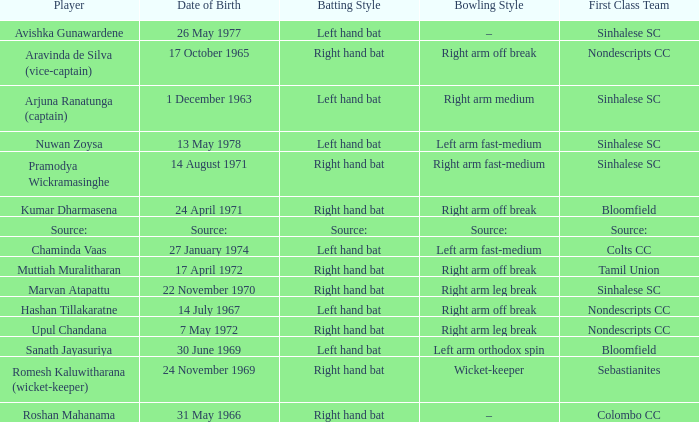When was avishka gunawardene born? 26 May 1977. 